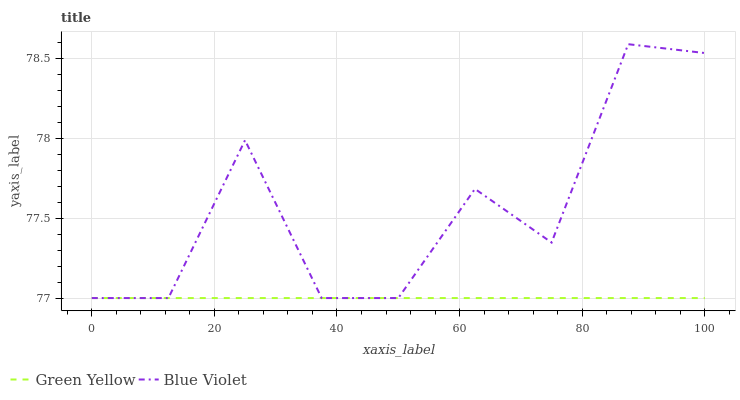Does Green Yellow have the minimum area under the curve?
Answer yes or no. Yes. Does Blue Violet have the maximum area under the curve?
Answer yes or no. Yes. Does Blue Violet have the minimum area under the curve?
Answer yes or no. No. Is Green Yellow the smoothest?
Answer yes or no. Yes. Is Blue Violet the roughest?
Answer yes or no. Yes. Is Blue Violet the smoothest?
Answer yes or no. No. Does Blue Violet have the highest value?
Answer yes or no. Yes. Does Blue Violet intersect Green Yellow?
Answer yes or no. Yes. Is Blue Violet less than Green Yellow?
Answer yes or no. No. Is Blue Violet greater than Green Yellow?
Answer yes or no. No. 